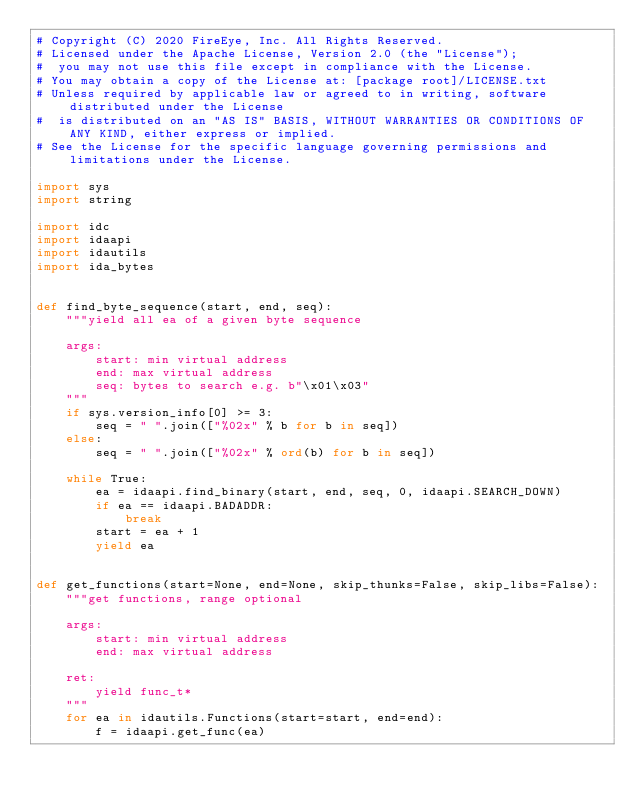Convert code to text. <code><loc_0><loc_0><loc_500><loc_500><_Python_># Copyright (C) 2020 FireEye, Inc. All Rights Reserved.
# Licensed under the Apache License, Version 2.0 (the "License");
#  you may not use this file except in compliance with the License.
# You may obtain a copy of the License at: [package root]/LICENSE.txt
# Unless required by applicable law or agreed to in writing, software distributed under the License
#  is distributed on an "AS IS" BASIS, WITHOUT WARRANTIES OR CONDITIONS OF ANY KIND, either express or implied.
# See the License for the specific language governing permissions and limitations under the License.

import sys
import string

import idc
import idaapi
import idautils
import ida_bytes


def find_byte_sequence(start, end, seq):
    """yield all ea of a given byte sequence

    args:
        start: min virtual address
        end: max virtual address
        seq: bytes to search e.g. b"\x01\x03"
    """
    if sys.version_info[0] >= 3:
        seq = " ".join(["%02x" % b for b in seq])
    else:
        seq = " ".join(["%02x" % ord(b) for b in seq])

    while True:
        ea = idaapi.find_binary(start, end, seq, 0, idaapi.SEARCH_DOWN)
        if ea == idaapi.BADADDR:
            break
        start = ea + 1
        yield ea


def get_functions(start=None, end=None, skip_thunks=False, skip_libs=False):
    """get functions, range optional

    args:
        start: min virtual address
        end: max virtual address

    ret:
        yield func_t*
    """
    for ea in idautils.Functions(start=start, end=end):
        f = idaapi.get_func(ea)</code> 